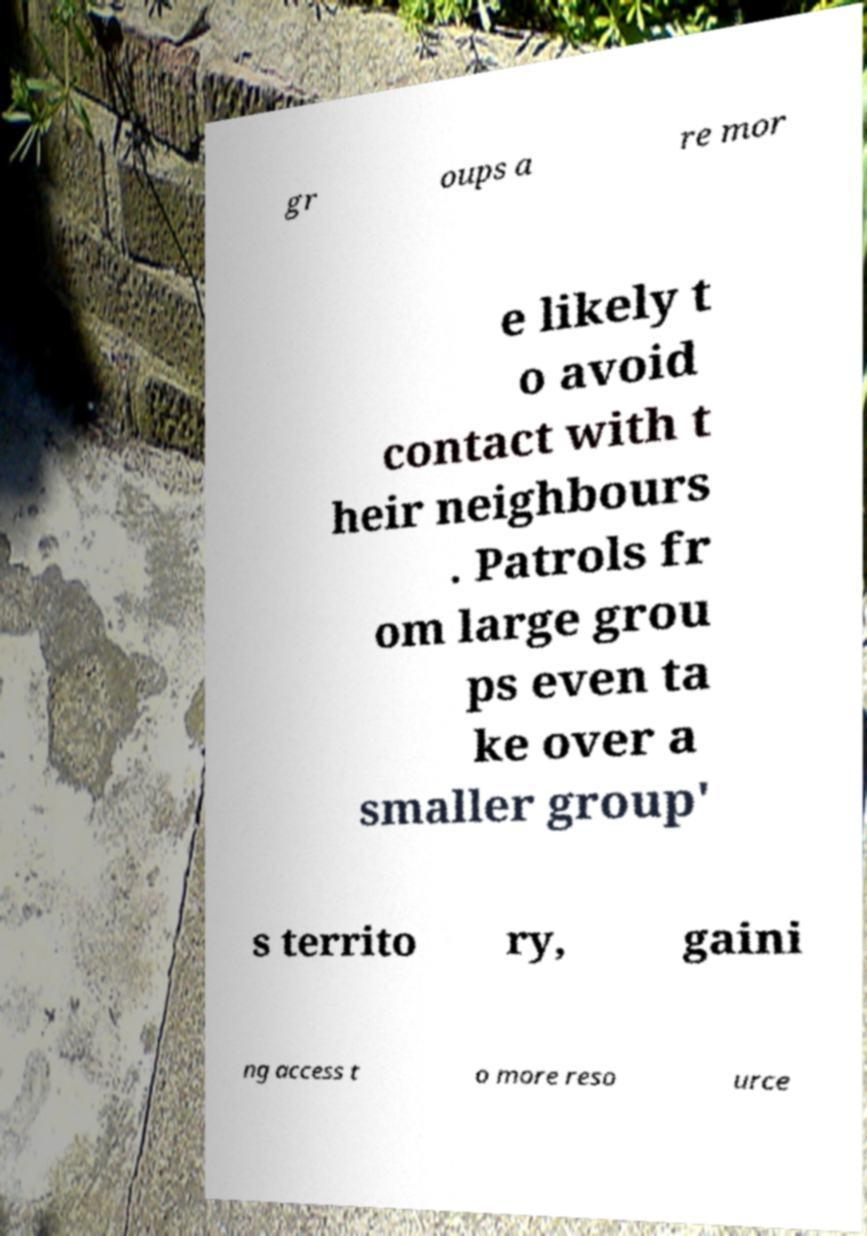Please identify and transcribe the text found in this image. gr oups a re mor e likely t o avoid contact with t heir neighbours . Patrols fr om large grou ps even ta ke over a smaller group' s territo ry, gaini ng access t o more reso urce 